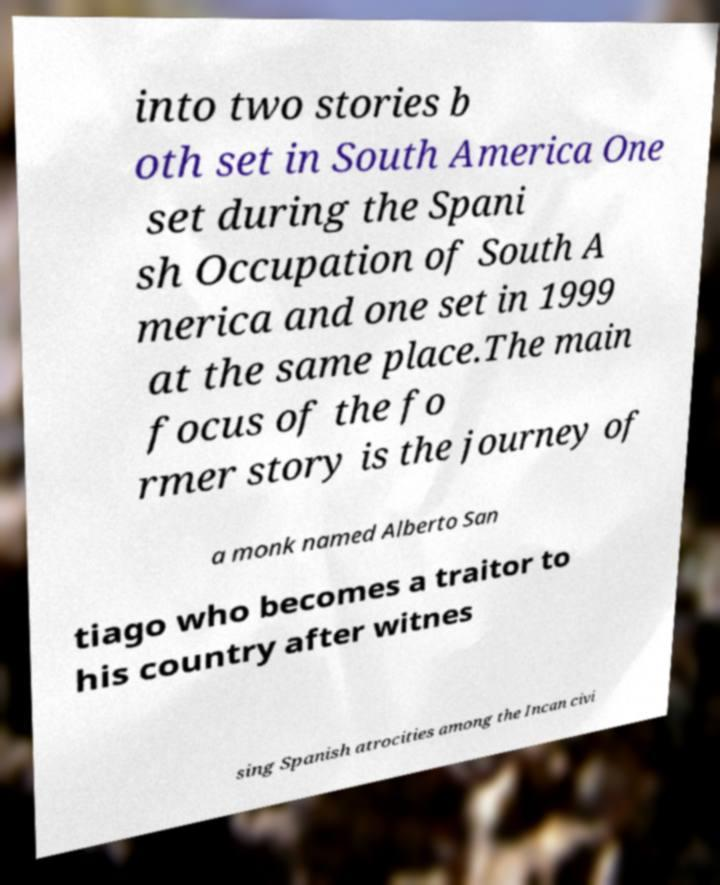Could you assist in decoding the text presented in this image and type it out clearly? into two stories b oth set in South America One set during the Spani sh Occupation of South A merica and one set in 1999 at the same place.The main focus of the fo rmer story is the journey of a monk named Alberto San tiago who becomes a traitor to his country after witnes sing Spanish atrocities among the Incan civi 